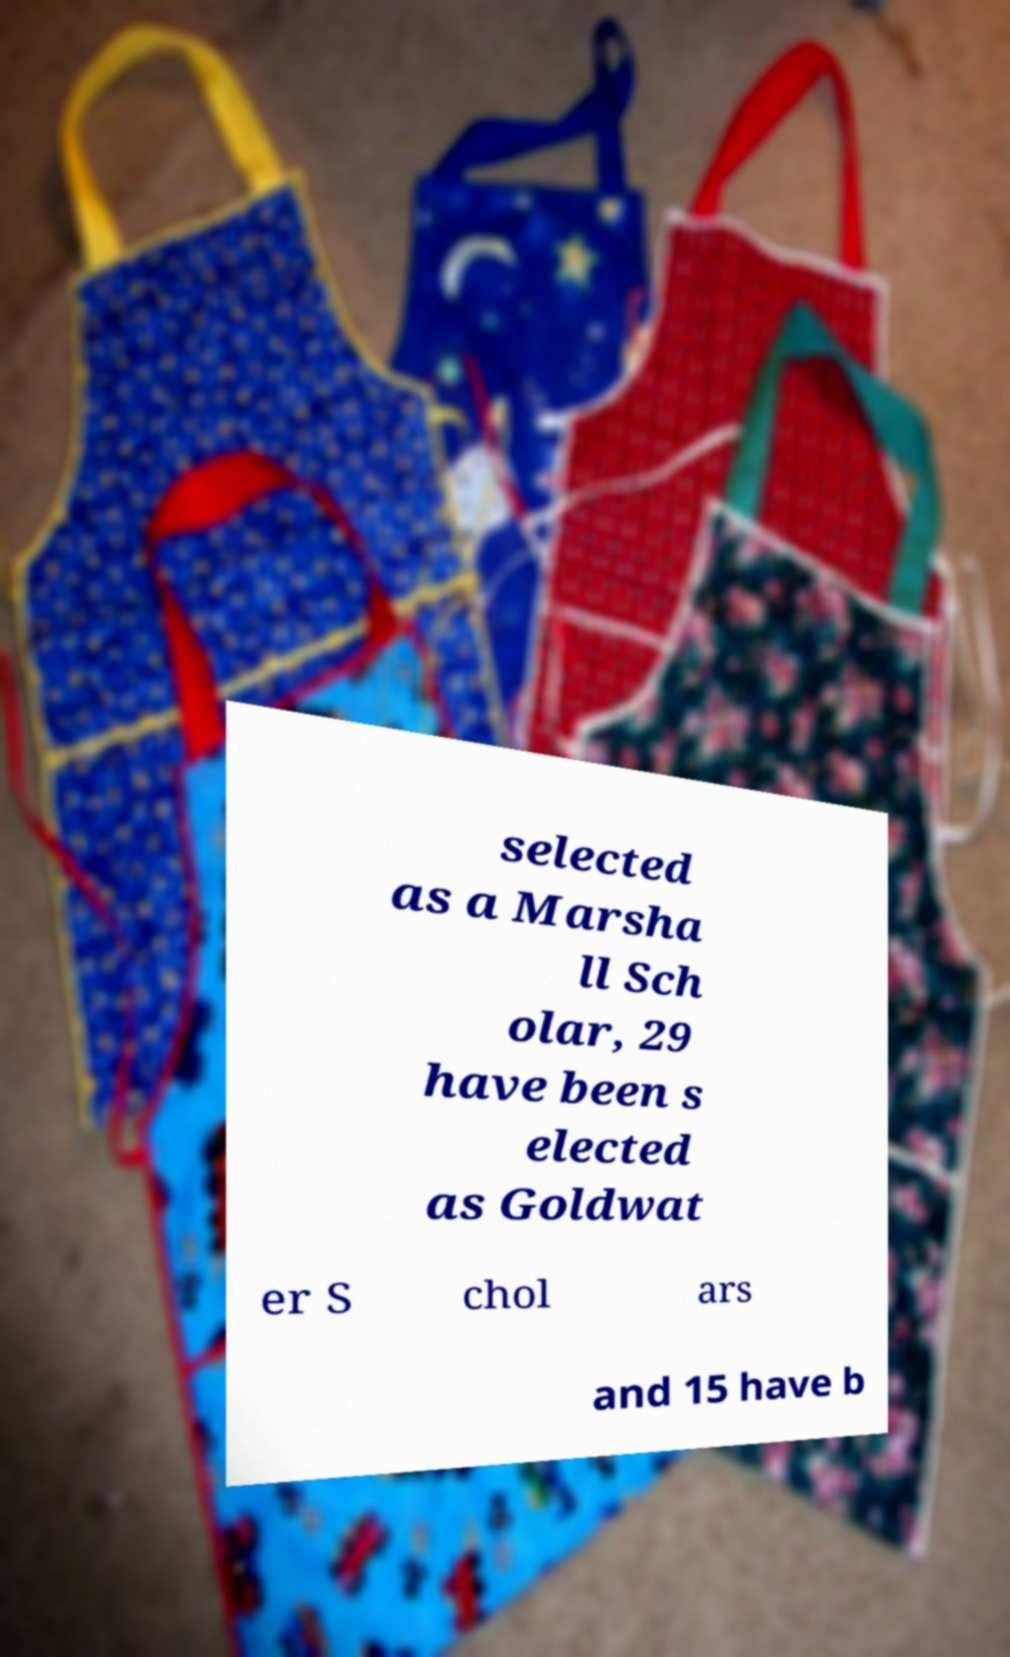There's text embedded in this image that I need extracted. Can you transcribe it verbatim? selected as a Marsha ll Sch olar, 29 have been s elected as Goldwat er S chol ars and 15 have b 